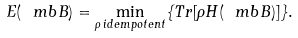Convert formula to latex. <formula><loc_0><loc_0><loc_500><loc_500>E ( \ m b B ) = \min _ { \rho \, i d e m p o t e n t } \{ T r [ \rho H ( \ m b B ) ] \} .</formula> 